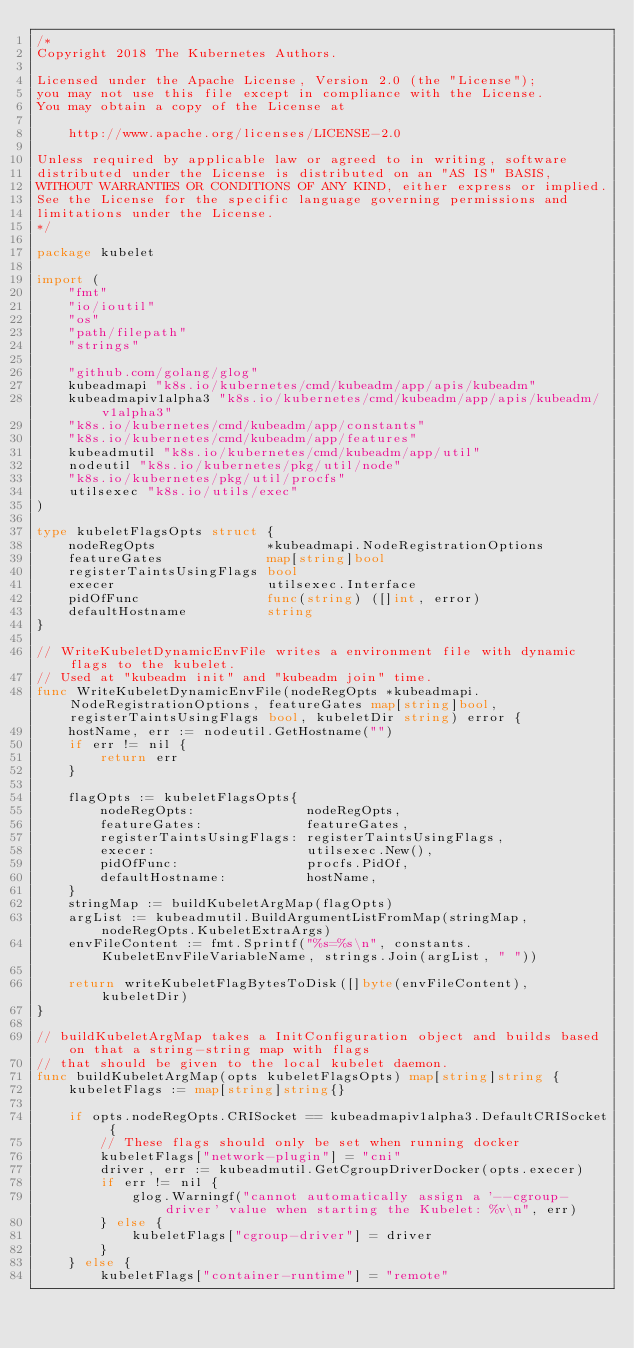Convert code to text. <code><loc_0><loc_0><loc_500><loc_500><_Go_>/*
Copyright 2018 The Kubernetes Authors.

Licensed under the Apache License, Version 2.0 (the "License");
you may not use this file except in compliance with the License.
You may obtain a copy of the License at

    http://www.apache.org/licenses/LICENSE-2.0

Unless required by applicable law or agreed to in writing, software
distributed under the License is distributed on an "AS IS" BASIS,
WITHOUT WARRANTIES OR CONDITIONS OF ANY KIND, either express or implied.
See the License for the specific language governing permissions and
limitations under the License.
*/

package kubelet

import (
	"fmt"
	"io/ioutil"
	"os"
	"path/filepath"
	"strings"

	"github.com/golang/glog"
	kubeadmapi "k8s.io/kubernetes/cmd/kubeadm/app/apis/kubeadm"
	kubeadmapiv1alpha3 "k8s.io/kubernetes/cmd/kubeadm/app/apis/kubeadm/v1alpha3"
	"k8s.io/kubernetes/cmd/kubeadm/app/constants"
	"k8s.io/kubernetes/cmd/kubeadm/app/features"
	kubeadmutil "k8s.io/kubernetes/cmd/kubeadm/app/util"
	nodeutil "k8s.io/kubernetes/pkg/util/node"
	"k8s.io/kubernetes/pkg/util/procfs"
	utilsexec "k8s.io/utils/exec"
)

type kubeletFlagsOpts struct {
	nodeRegOpts              *kubeadmapi.NodeRegistrationOptions
	featureGates             map[string]bool
	registerTaintsUsingFlags bool
	execer                   utilsexec.Interface
	pidOfFunc                func(string) ([]int, error)
	defaultHostname          string
}

// WriteKubeletDynamicEnvFile writes a environment file with dynamic flags to the kubelet.
// Used at "kubeadm init" and "kubeadm join" time.
func WriteKubeletDynamicEnvFile(nodeRegOpts *kubeadmapi.NodeRegistrationOptions, featureGates map[string]bool, registerTaintsUsingFlags bool, kubeletDir string) error {
	hostName, err := nodeutil.GetHostname("")
	if err != nil {
		return err
	}

	flagOpts := kubeletFlagsOpts{
		nodeRegOpts:              nodeRegOpts,
		featureGates:             featureGates,
		registerTaintsUsingFlags: registerTaintsUsingFlags,
		execer:                   utilsexec.New(),
		pidOfFunc:                procfs.PidOf,
		defaultHostname:          hostName,
	}
	stringMap := buildKubeletArgMap(flagOpts)
	argList := kubeadmutil.BuildArgumentListFromMap(stringMap, nodeRegOpts.KubeletExtraArgs)
	envFileContent := fmt.Sprintf("%s=%s\n", constants.KubeletEnvFileVariableName, strings.Join(argList, " "))

	return writeKubeletFlagBytesToDisk([]byte(envFileContent), kubeletDir)
}

// buildKubeletArgMap takes a InitConfiguration object and builds based on that a string-string map with flags
// that should be given to the local kubelet daemon.
func buildKubeletArgMap(opts kubeletFlagsOpts) map[string]string {
	kubeletFlags := map[string]string{}

	if opts.nodeRegOpts.CRISocket == kubeadmapiv1alpha3.DefaultCRISocket {
		// These flags should only be set when running docker
		kubeletFlags["network-plugin"] = "cni"
		driver, err := kubeadmutil.GetCgroupDriverDocker(opts.execer)
		if err != nil {
			glog.Warningf("cannot automatically assign a '--cgroup-driver' value when starting the Kubelet: %v\n", err)
		} else {
			kubeletFlags["cgroup-driver"] = driver
		}
	} else {
		kubeletFlags["container-runtime"] = "remote"</code> 